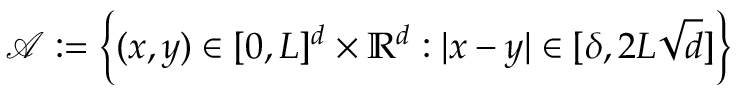<formula> <loc_0><loc_0><loc_500><loc_500>\mathcal { A } \colon = \left \{ ( x , y ) \in [ 0 , L ] ^ { d } \times \mathbb { R } ^ { d } \colon | x - y | \in [ \delta , 2 L \sqrt { d } ] \right \}</formula> 